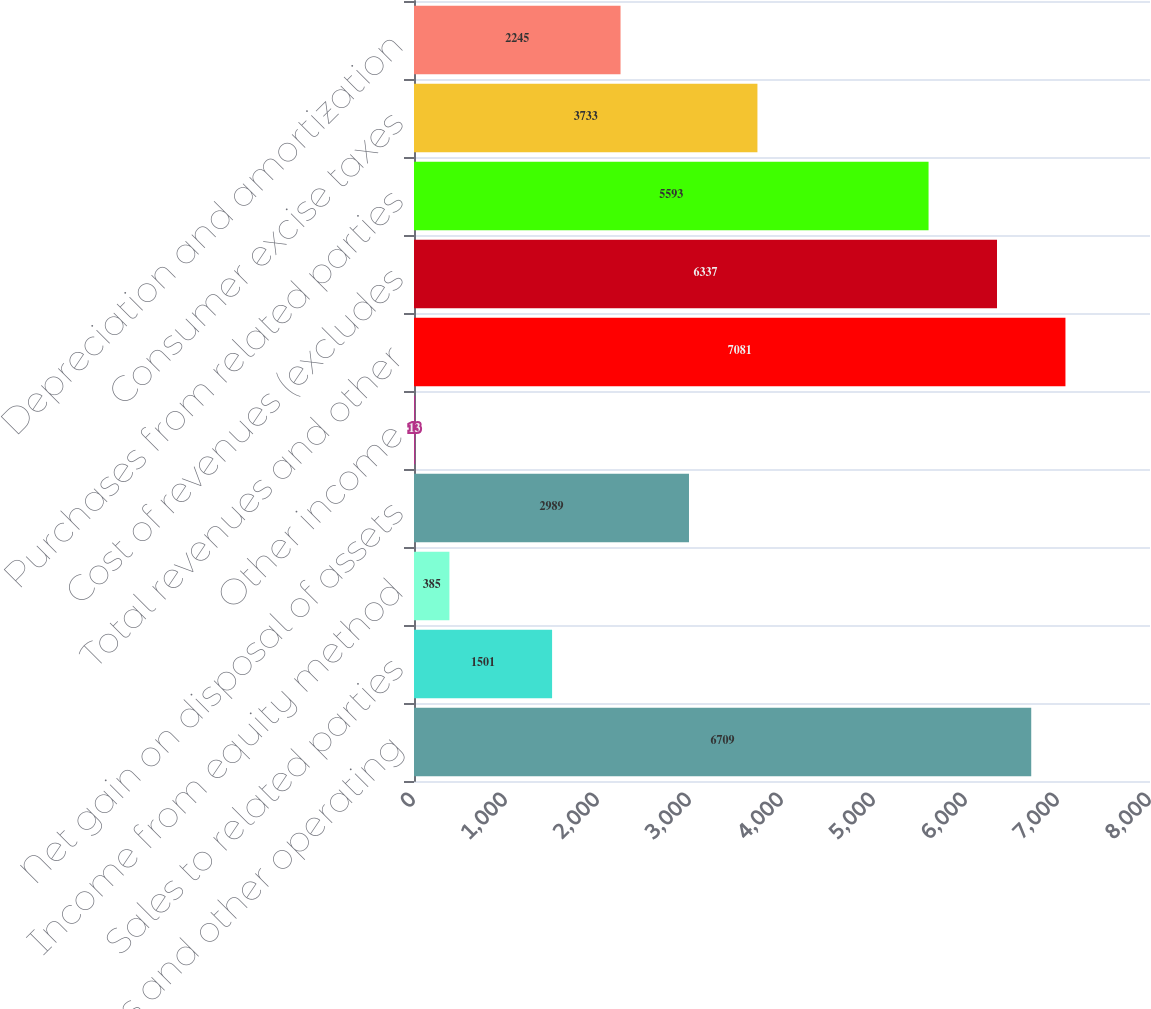Convert chart to OTSL. <chart><loc_0><loc_0><loc_500><loc_500><bar_chart><fcel>Sales and other operating<fcel>Sales to related parties<fcel>Income from equity method<fcel>Net gain on disposal of assets<fcel>Other income<fcel>Total revenues and other<fcel>Cost of revenues (excludes<fcel>Purchases from related parties<fcel>Consumer excise taxes<fcel>Depreciation and amortization<nl><fcel>6709<fcel>1501<fcel>385<fcel>2989<fcel>13<fcel>7081<fcel>6337<fcel>5593<fcel>3733<fcel>2245<nl></chart> 